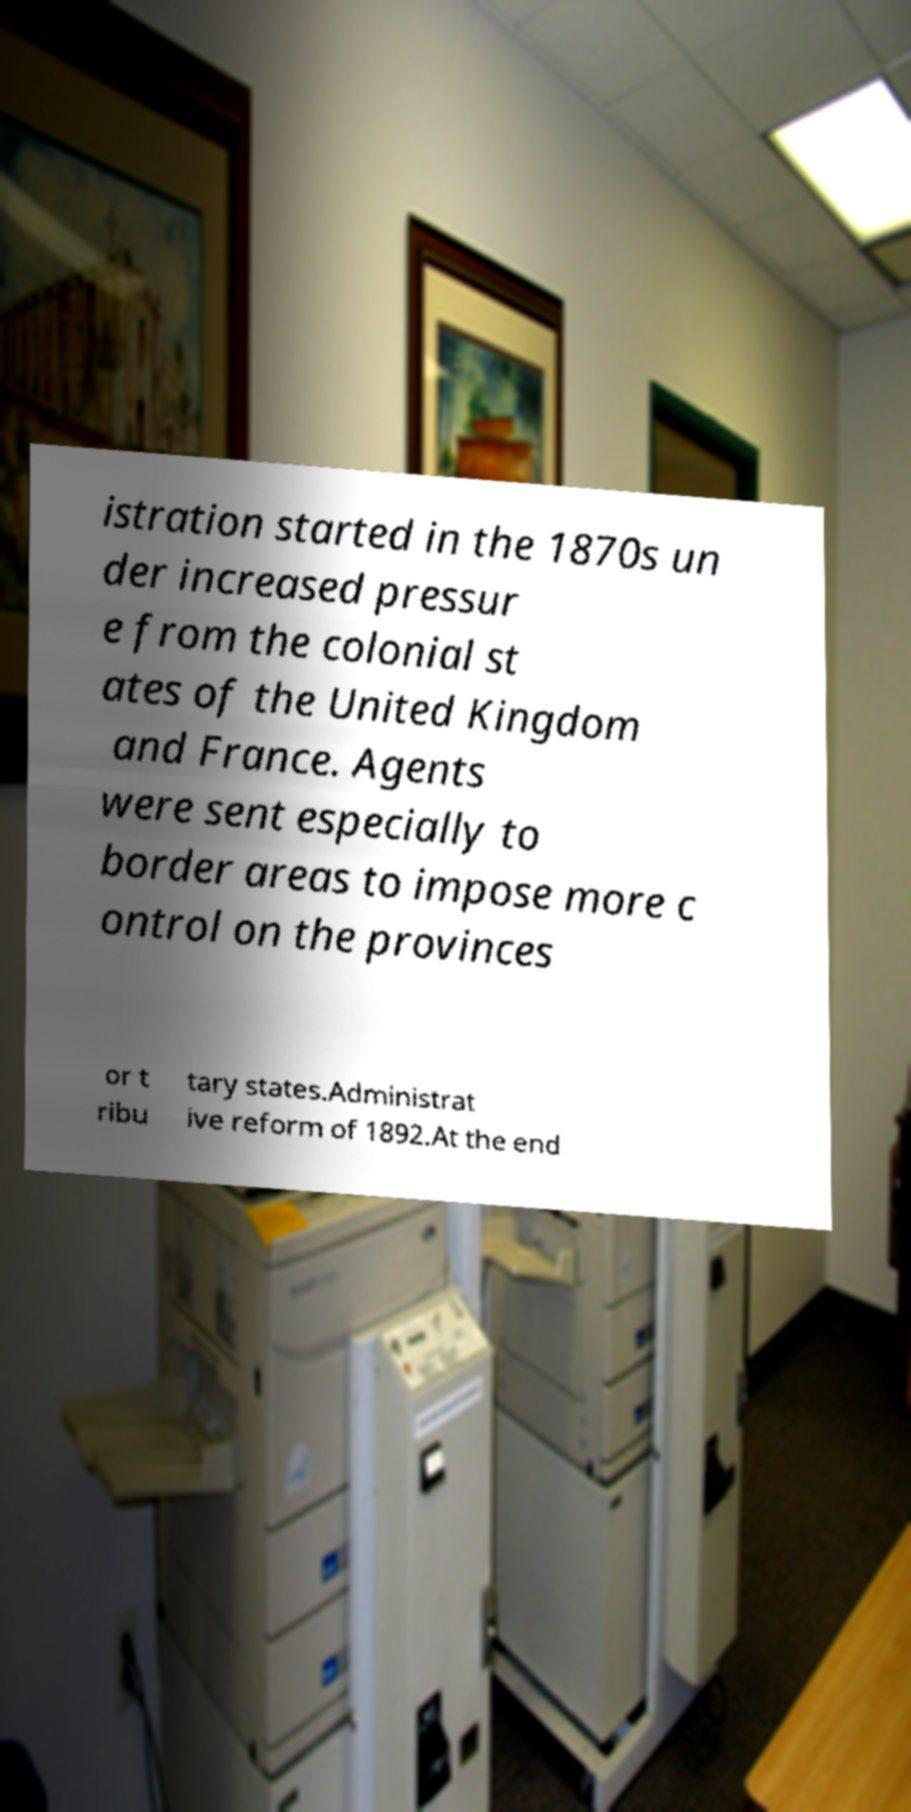Can you accurately transcribe the text from the provided image for me? istration started in the 1870s un der increased pressur e from the colonial st ates of the United Kingdom and France. Agents were sent especially to border areas to impose more c ontrol on the provinces or t ribu tary states.Administrat ive reform of 1892.At the end 